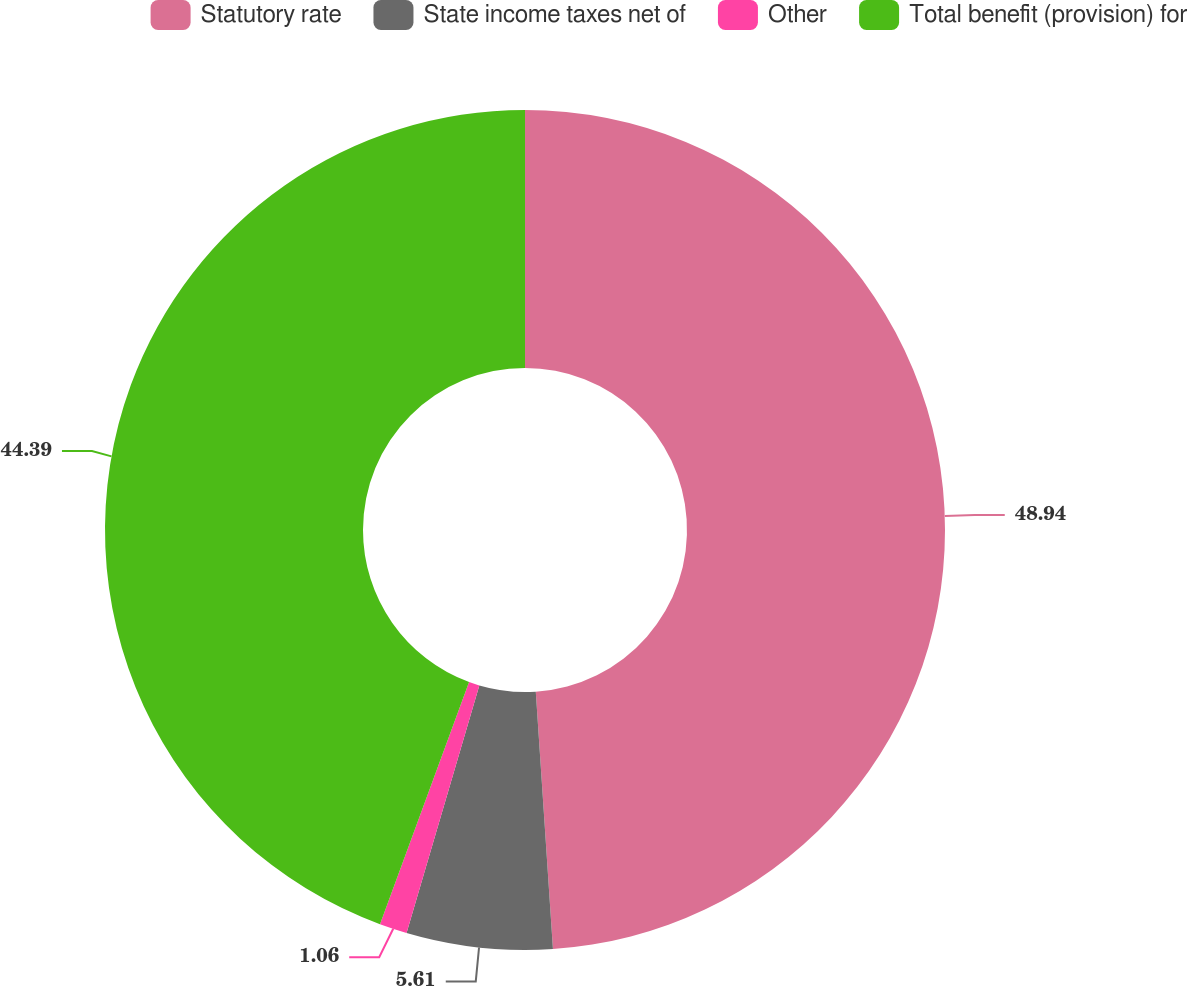Convert chart to OTSL. <chart><loc_0><loc_0><loc_500><loc_500><pie_chart><fcel>Statutory rate<fcel>State income taxes net of<fcel>Other<fcel>Total benefit (provision) for<nl><fcel>48.94%<fcel>5.61%<fcel>1.06%<fcel>44.39%<nl></chart> 